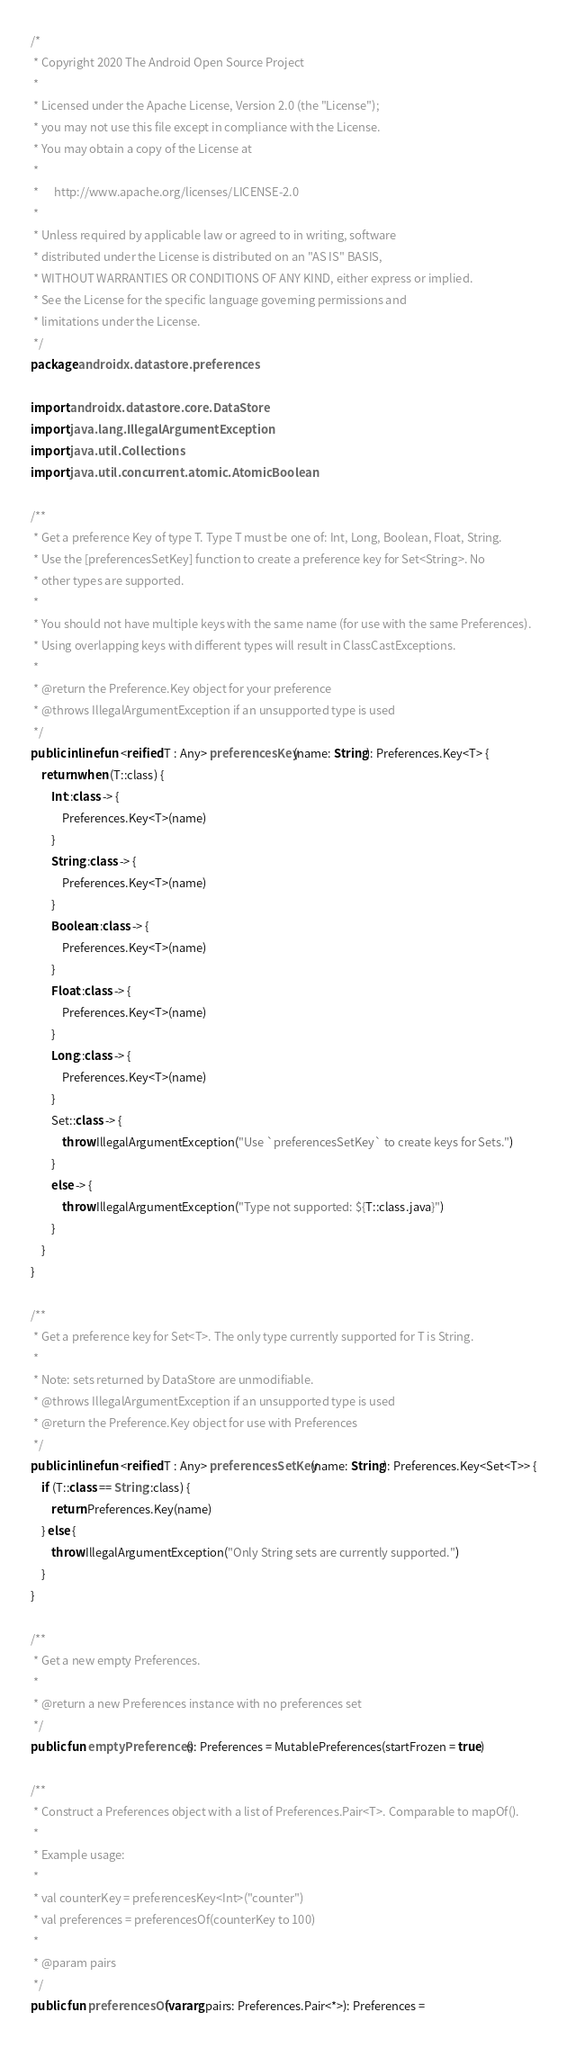<code> <loc_0><loc_0><loc_500><loc_500><_Kotlin_>/*
 * Copyright 2020 The Android Open Source Project
 *
 * Licensed under the Apache License, Version 2.0 (the "License");
 * you may not use this file except in compliance with the License.
 * You may obtain a copy of the License at
 *
 *      http://www.apache.org/licenses/LICENSE-2.0
 *
 * Unless required by applicable law or agreed to in writing, software
 * distributed under the License is distributed on an "AS IS" BASIS,
 * WITHOUT WARRANTIES OR CONDITIONS OF ANY KIND, either express or implied.
 * See the License for the specific language governing permissions and
 * limitations under the License.
 */
package androidx.datastore.preferences

import androidx.datastore.core.DataStore
import java.lang.IllegalArgumentException
import java.util.Collections
import java.util.concurrent.atomic.AtomicBoolean

/**
 * Get a preference Key of type T. Type T must be one of: Int, Long, Boolean, Float, String.
 * Use the [preferencesSetKey] function to create a preference key for Set<String>. No
 * other types are supported.
 *
 * You should not have multiple keys with the same name (for use with the same Preferences).
 * Using overlapping keys with different types will result in ClassCastExceptions.
 *
 * @return the Preference.Key object for your preference
 * @throws IllegalArgumentException if an unsupported type is used
 */
public inline fun <reified T : Any> preferencesKey(name: String): Preferences.Key<T> {
    return when (T::class) {
        Int::class -> {
            Preferences.Key<T>(name)
        }
        String::class -> {
            Preferences.Key<T>(name)
        }
        Boolean::class -> {
            Preferences.Key<T>(name)
        }
        Float::class -> {
            Preferences.Key<T>(name)
        }
        Long::class -> {
            Preferences.Key<T>(name)
        }
        Set::class -> {
            throw IllegalArgumentException("Use `preferencesSetKey` to create keys for Sets.")
        }
        else -> {
            throw IllegalArgumentException("Type not supported: ${T::class.java}")
        }
    }
}

/**
 * Get a preference key for Set<T>. The only type currently supported for T is String.
 *
 * Note: sets returned by DataStore are unmodifiable.
 * @throws IllegalArgumentException if an unsupported type is used
 * @return the Preference.Key object for use with Preferences
 */
public inline fun <reified T : Any> preferencesSetKey(name: String): Preferences.Key<Set<T>> {
    if (T::class == String::class) {
        return Preferences.Key(name)
    } else {
        throw IllegalArgumentException("Only String sets are currently supported.")
    }
}

/**
 * Get a new empty Preferences.
 *
 * @return a new Preferences instance with no preferences set
 */
public fun emptyPreferences(): Preferences = MutablePreferences(startFrozen = true)

/**
 * Construct a Preferences object with a list of Preferences.Pair<T>. Comparable to mapOf().
 *
 * Example usage:
 *
 * val counterKey = preferencesKey<Int>("counter")
 * val preferences = preferencesOf(counterKey to 100)
 *
 * @param pairs
 */
public fun preferencesOf(vararg pairs: Preferences.Pair<*>): Preferences =</code> 